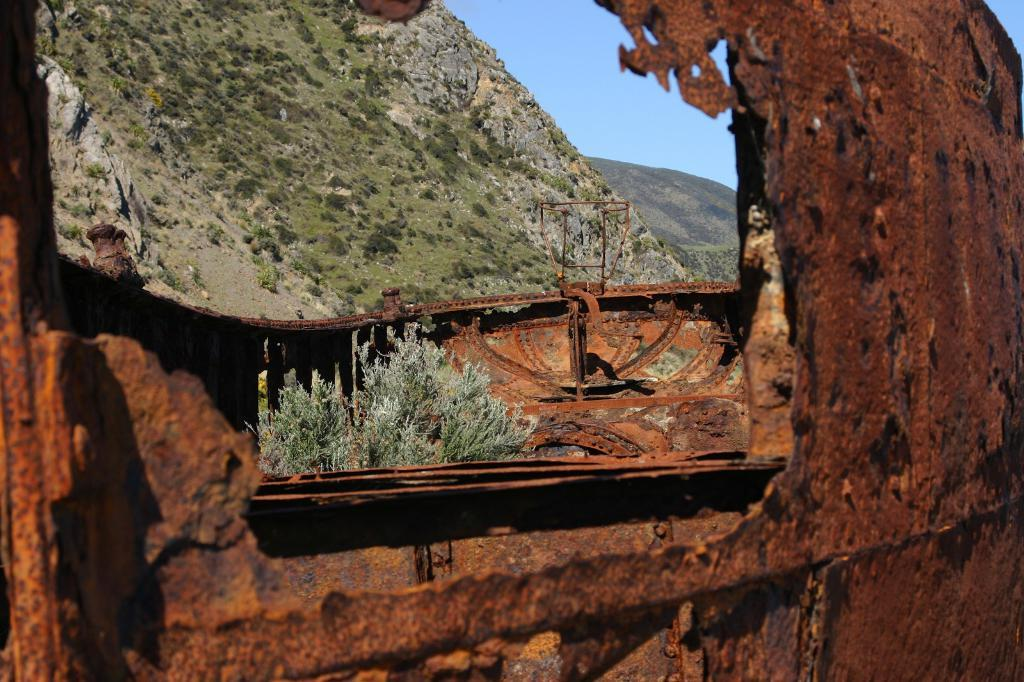What type of material is the object in the image made of? The object in the image is made of an old iron sheet. What can be seen in the distance behind the iron sheet? There are mountains in the background of the image. What part of the natural environment is visible in the image? The sky is visible in the background of the image. What type of account is being discussed in the image? There is no account being discussed in the image; it features an old iron sheet and a background with mountains and the sky. 